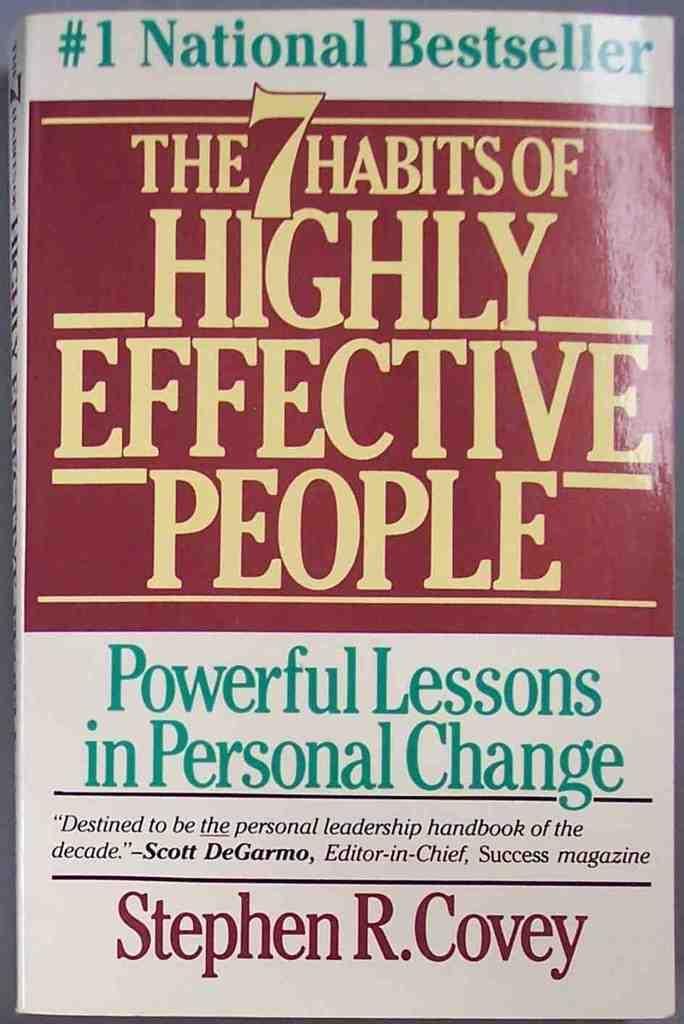<image>
Offer a succinct explanation of the picture presented. The book shown is written by a national bestseller author. 